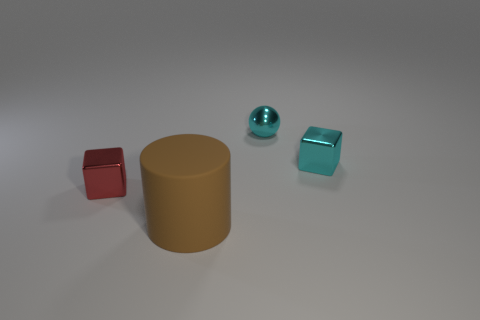Is there anything else that is made of the same material as the large brown object?
Your answer should be compact. No. What number of things are either tiny red blocks or cyan objects in front of the small ball?
Make the answer very short. 2. Is the size of the block that is on the left side of the brown matte object the same as the cube that is right of the small red block?
Provide a short and direct response. Yes. What number of tiny cyan metal things are the same shape as the tiny red object?
Keep it short and to the point. 1. The cyan object that is the same material as the cyan cube is what shape?
Provide a short and direct response. Sphere. There is a cube that is on the right side of the tiny object that is in front of the metallic block that is right of the small red thing; what is its material?
Offer a terse response. Metal. There is a red block; is it the same size as the metallic block that is behind the red shiny thing?
Your response must be concise. Yes. There is a cyan object that is the same shape as the small red metallic thing; what is it made of?
Your answer should be very brief. Metal. What is the size of the cube that is right of the metallic object that is behind the shiny cube on the right side of the large brown matte thing?
Offer a terse response. Small. Does the cyan metal block have the same size as the red cube?
Make the answer very short. Yes. 